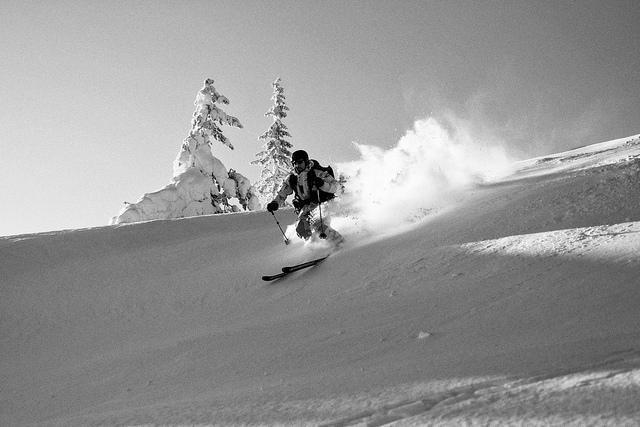How many trucks do you see?
Give a very brief answer. 0. How many skiers are there?
Give a very brief answer. 1. How many buses are red and white striped?
Give a very brief answer. 0. 